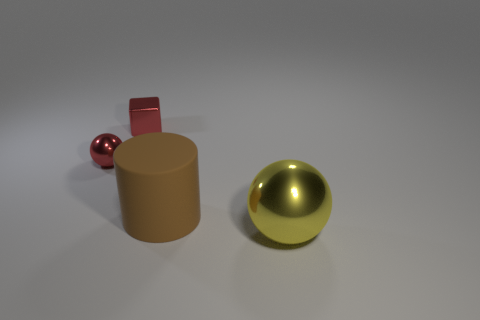Are there fewer large brown cylinders on the right side of the brown rubber object than purple metal cubes?
Make the answer very short. No. Is the material of the yellow ball the same as the sphere that is behind the cylinder?
Your answer should be compact. Yes. There is a shiny ball that is behind the metal sphere on the right side of the rubber cylinder; is there a red metallic thing behind it?
Make the answer very short. Yes. The small ball that is the same material as the tiny cube is what color?
Ensure brevity in your answer.  Red. How big is the metallic object that is both on the right side of the small red shiny ball and left of the large yellow metallic sphere?
Provide a succinct answer. Small. Are there fewer small objects on the right side of the big brown thing than small red metallic objects that are behind the small ball?
Give a very brief answer. Yes. Does the tiny red thing in front of the small red block have the same material as the thing in front of the large brown cylinder?
Provide a succinct answer. Yes. What is the material of the tiny thing that is the same color as the cube?
Keep it short and to the point. Metal. What is the shape of the metal object that is on the right side of the small ball and to the left of the brown rubber thing?
Keep it short and to the point. Cube. What is the material of the sphere in front of the big thing that is on the left side of the large shiny ball?
Provide a short and direct response. Metal. 